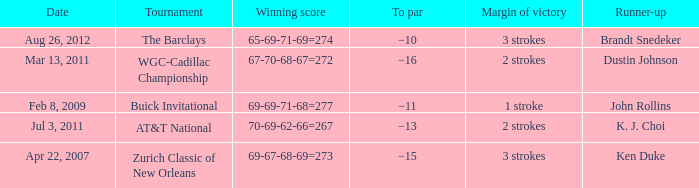A tournament on which date has a margin of victory of 2 strokes and a par of −16? Mar 13, 2011. 